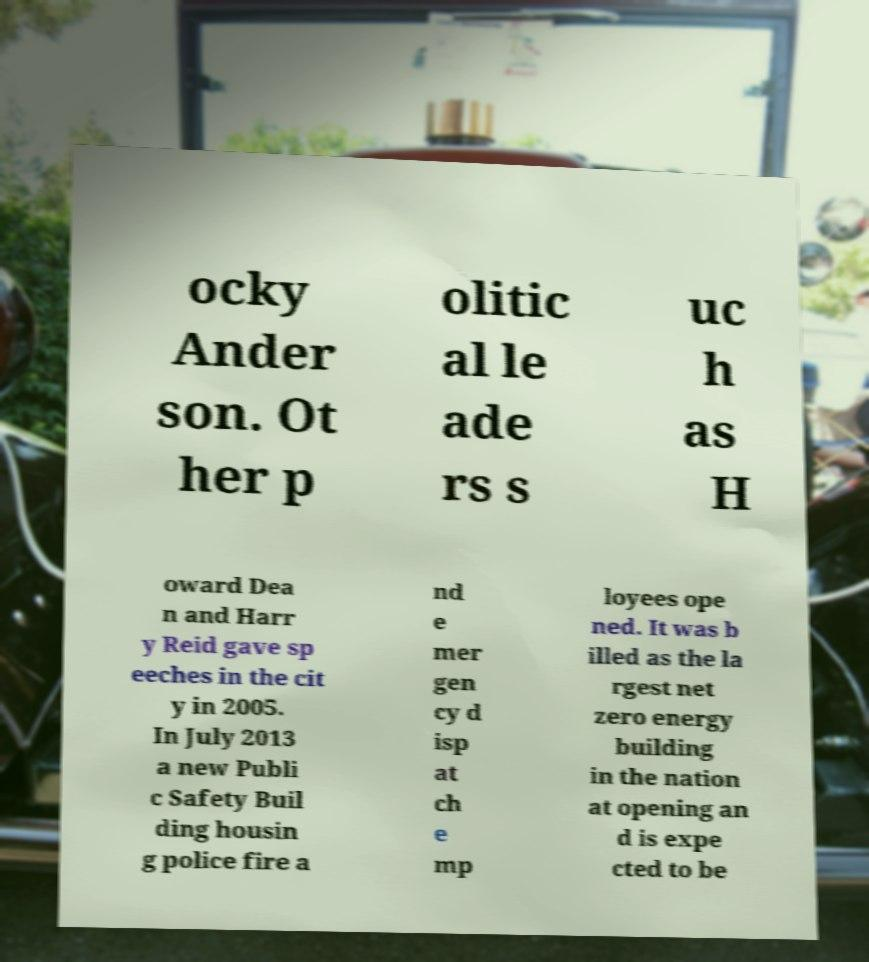There's text embedded in this image that I need extracted. Can you transcribe it verbatim? ocky Ander son. Ot her p olitic al le ade rs s uc h as H oward Dea n and Harr y Reid gave sp eeches in the cit y in 2005. In July 2013 a new Publi c Safety Buil ding housin g police fire a nd e mer gen cy d isp at ch e mp loyees ope ned. It was b illed as the la rgest net zero energy building in the nation at opening an d is expe cted to be 